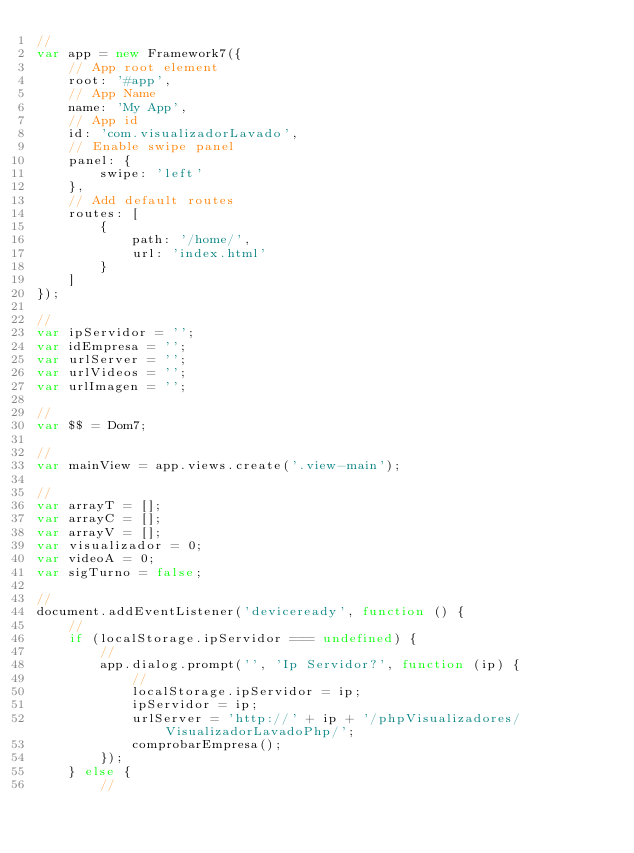Convert code to text. <code><loc_0><loc_0><loc_500><loc_500><_JavaScript_>//
var app = new Framework7({
    // App root element
    root: '#app',
    // App Name
    name: 'My App',
    // App id
    id: 'com.visualizadorLavado',
    // Enable swipe panel
    panel: {
        swipe: 'left'
    },
    // Add default routes
    routes: [
        {
            path: '/home/',
            url: 'index.html'
        }
    ]
});

//
var ipServidor = '';
var idEmpresa = '';
var urlServer = '';
var urlVideos = '';
var urlImagen = '';

//
var $$ = Dom7;

//
var mainView = app.views.create('.view-main');

//
var arrayT = [];
var arrayC = [];
var arrayV = [];
var visualizador = 0;
var videoA = 0;
var sigTurno = false;

//
document.addEventListener('deviceready', function () {
    //
    if (localStorage.ipServidor === undefined) {
        //
        app.dialog.prompt('', 'Ip Servidor?', function (ip) {
            //
            localStorage.ipServidor = ip;
            ipServidor = ip;
            urlServer = 'http://' + ip + '/phpVisualizadores/VisualizadorLavadoPhp/';
            comprobarEmpresa();
        });
    } else {
        //</code> 